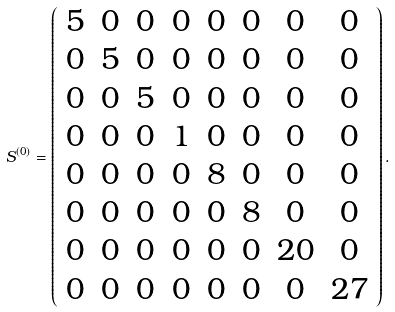Convert formula to latex. <formula><loc_0><loc_0><loc_500><loc_500>S ^ { ( 0 ) } = \left ( \begin{array} [ c ] { c c c c c c c c } 5 & 0 & 0 & 0 & 0 & 0 & 0 & 0 \\ 0 & 5 & 0 & 0 & 0 & 0 & 0 & 0 \\ 0 & 0 & 5 & 0 & 0 & 0 & 0 & 0 \\ 0 & 0 & 0 & 1 & 0 & 0 & 0 & 0 \\ 0 & 0 & 0 & 0 & 8 & 0 & 0 & 0 \\ 0 & 0 & 0 & 0 & 0 & 8 & 0 & 0 \\ 0 & 0 & 0 & 0 & 0 & 0 & 2 0 & 0 \\ 0 & 0 & 0 & 0 & 0 & 0 & 0 & 2 7 \end{array} \right ) .</formula> 